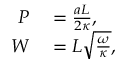Convert formula to latex. <formula><loc_0><loc_0><loc_500><loc_500>\begin{array} { r l } { P } & = \frac { a L } { 2 \kappa } , } \\ { W } & = L \sqrt { \frac { \omega } { \kappa } } , } \end{array}</formula> 